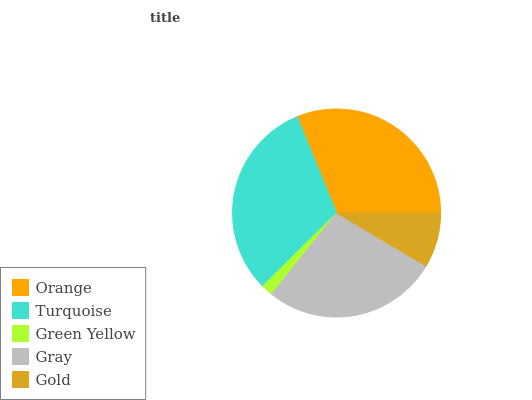Is Green Yellow the minimum?
Answer yes or no. Yes. Is Turquoise the maximum?
Answer yes or no. Yes. Is Turquoise the minimum?
Answer yes or no. No. Is Green Yellow the maximum?
Answer yes or no. No. Is Turquoise greater than Green Yellow?
Answer yes or no. Yes. Is Green Yellow less than Turquoise?
Answer yes or no. Yes. Is Green Yellow greater than Turquoise?
Answer yes or no. No. Is Turquoise less than Green Yellow?
Answer yes or no. No. Is Gray the high median?
Answer yes or no. Yes. Is Gray the low median?
Answer yes or no. Yes. Is Turquoise the high median?
Answer yes or no. No. Is Turquoise the low median?
Answer yes or no. No. 